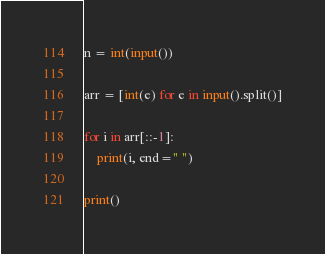Convert code to text. <code><loc_0><loc_0><loc_500><loc_500><_Python_>n = int(input())

arr = [int(e) for e in input().split()]

for i in arr[::-1]:
    print(i, end=" ")

print()</code> 